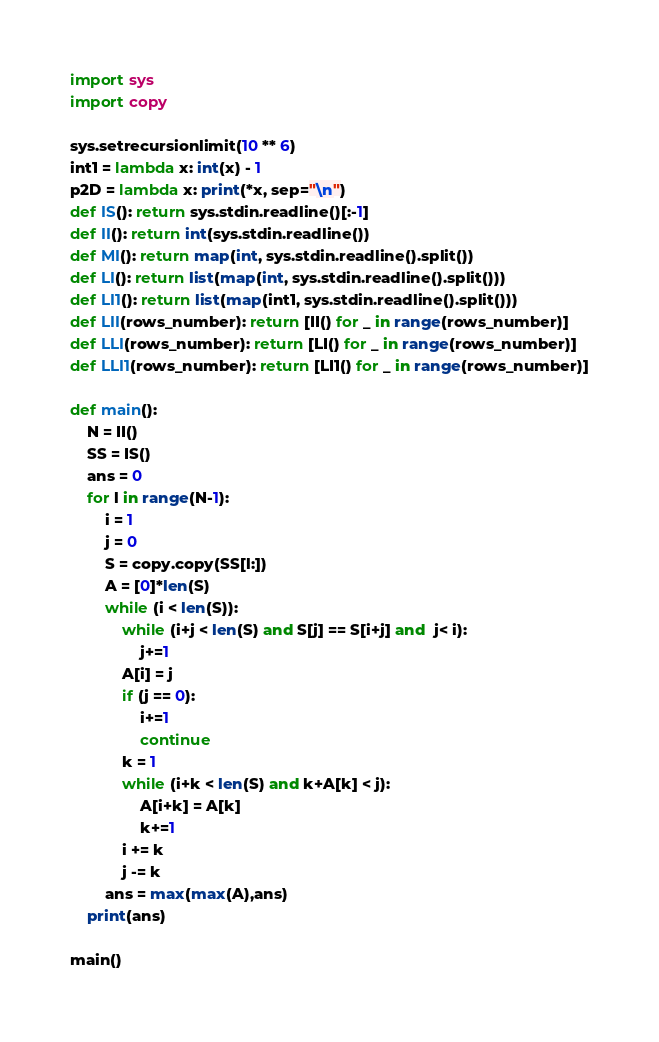Convert code to text. <code><loc_0><loc_0><loc_500><loc_500><_Python_>import sys
import copy

sys.setrecursionlimit(10 ** 6)
int1 = lambda x: int(x) - 1
p2D = lambda x: print(*x, sep="\n")
def IS(): return sys.stdin.readline()[:-1]
def II(): return int(sys.stdin.readline())
def MI(): return map(int, sys.stdin.readline().split())
def LI(): return list(map(int, sys.stdin.readline().split()))
def LI1(): return list(map(int1, sys.stdin.readline().split()))
def LII(rows_number): return [II() for _ in range(rows_number)]
def LLI(rows_number): return [LI() for _ in range(rows_number)]
def LLI1(rows_number): return [LI1() for _ in range(rows_number)]

def main():
	N = II()
	SS = IS()
	ans = 0
	for l in range(N-1):
		i = 1
		j = 0
		S = copy.copy(SS[l:])
		A = [0]*len(S)
		while (i < len(S)):
			while (i+j < len(S) and S[j] == S[i+j] and  j< i):
				j+=1
			A[i] = j
			if (j == 0):
				i+=1
				continue
			k = 1
			while (i+k < len(S) and k+A[k] < j):
				A[i+k] = A[k]
				k+=1
			i += k
			j -= k
		ans = max(max(A),ans)
	print(ans)

main()</code> 